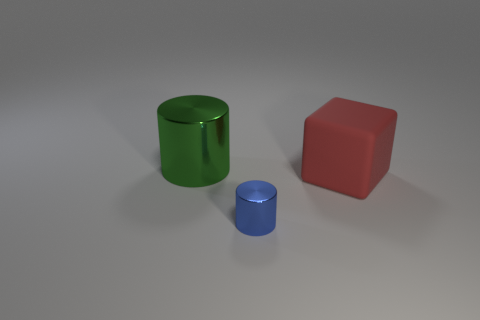Add 3 big red matte spheres. How many objects exist? 6 Subtract all cylinders. How many objects are left? 1 Add 3 small objects. How many small objects exist? 4 Subtract 0 blue balls. How many objects are left? 3 Subtract all tiny cyan cylinders. Subtract all blue things. How many objects are left? 2 Add 1 big matte objects. How many big matte objects are left? 2 